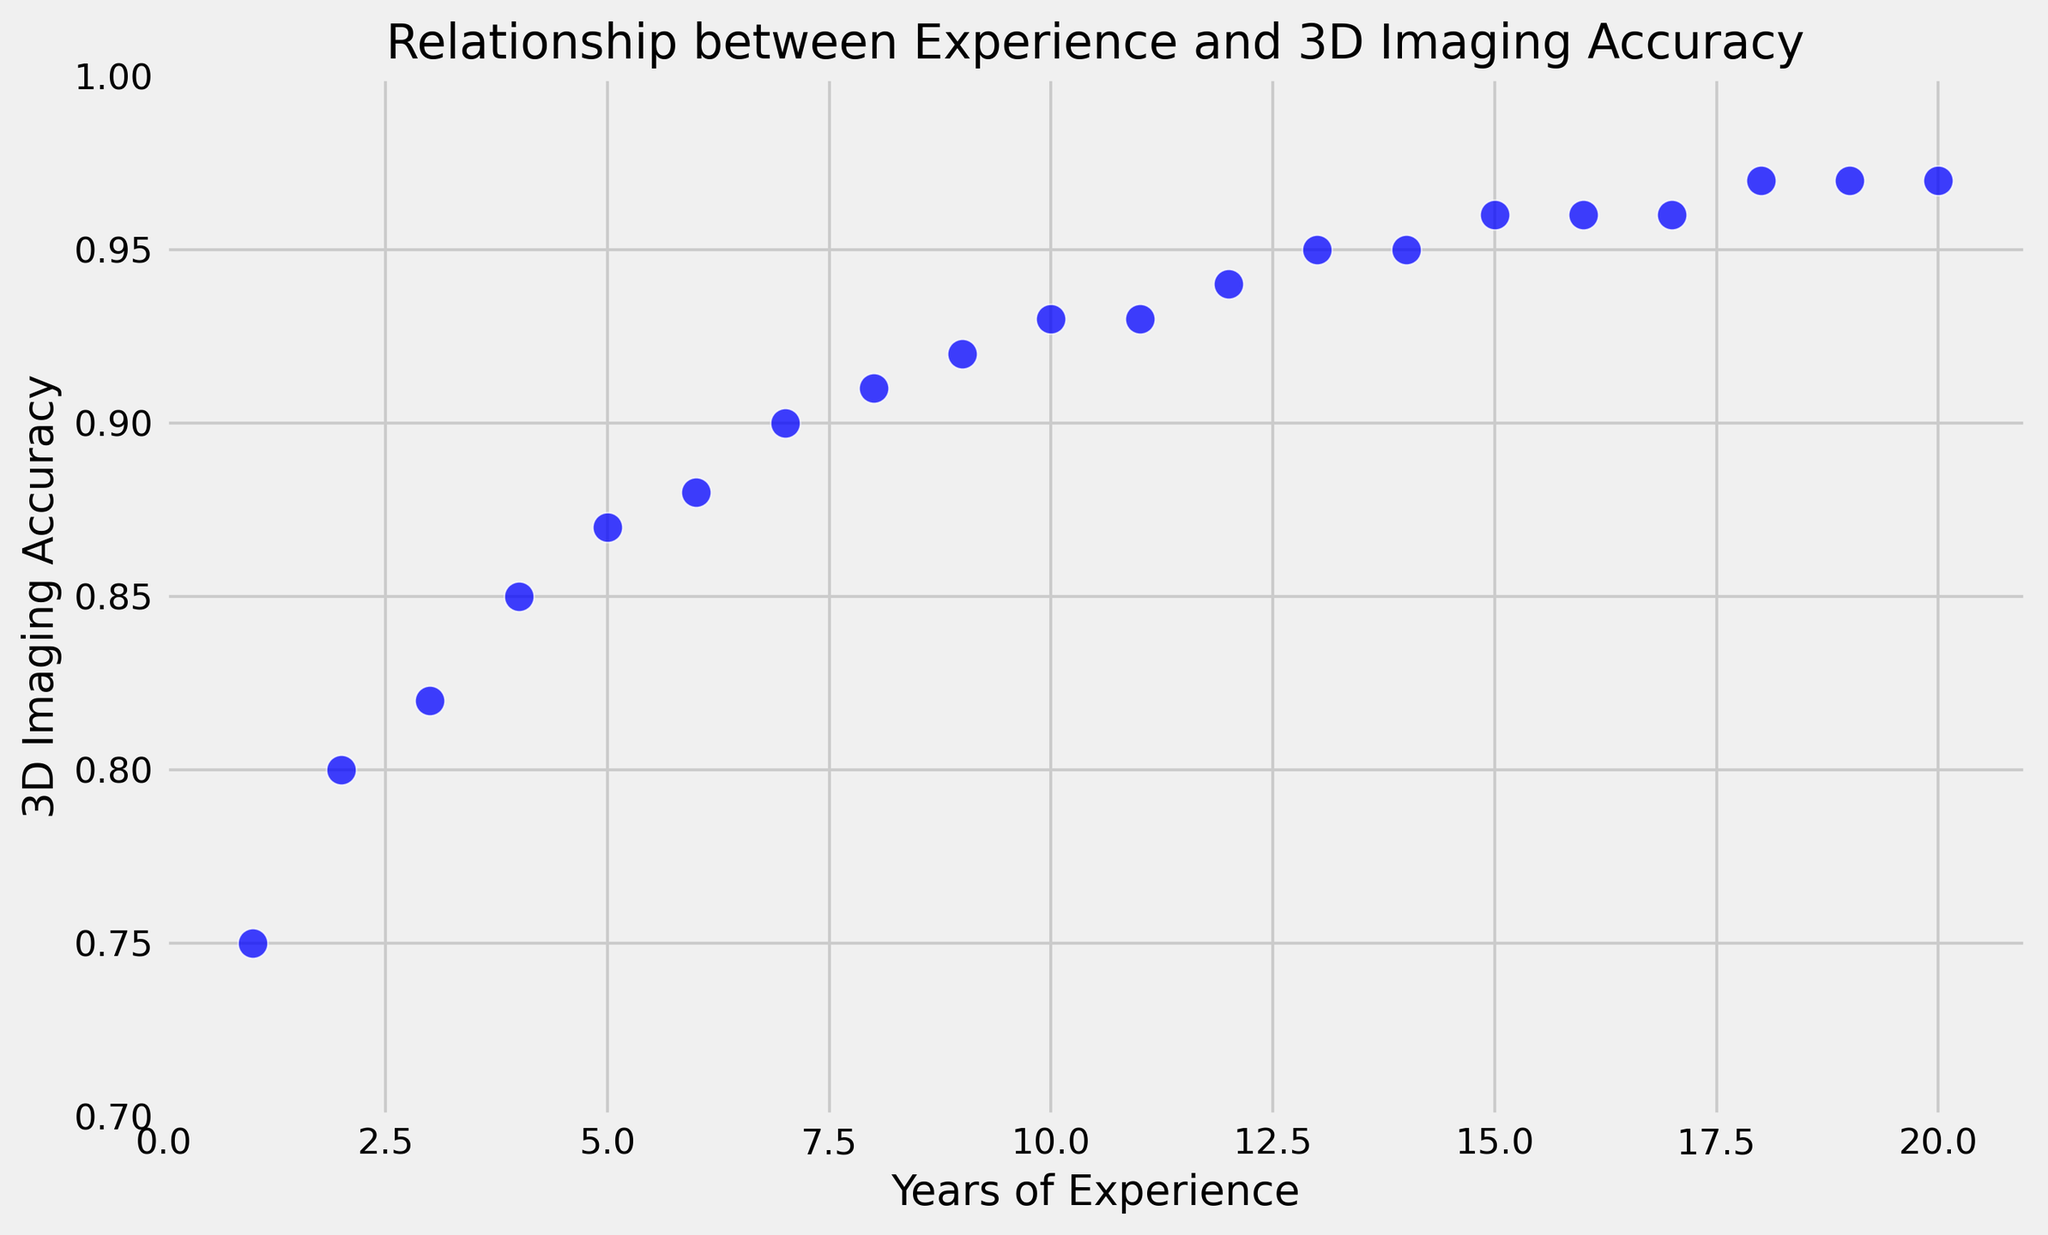What's the general trend depicted in the scatter plot? The scatter plot shows a positive correlation between years of experience and 3D imaging accuracy. As the years of experience increase, the 3D imaging accuracy also improves, indicating that more experienced software engineers tend to produce more accurate 3D imaging results for orthodontic planning.
Answer: Positive correlation What is the highest accuracy observed, and what is the corresponding years of experience? The highest accuracy observed in the scatter plot is 0.97, and this accuracy corresponds to software engineers with 18 to 20 years of experience.
Answer: 0.97, 18-20 years At how many years of experience do 3D imaging accuracy values begin to plateau? From the plot, 3D imaging accuracy values begin to plateau around 15 years of experience, where the accuracy hovers between 0.95 and 0.97.
Answer: 15 years What is the accuracy range for software engineers with 5 to 10 years of experience? For software engineers with 5 to 10 years of experience, the 3D imaging accuracy ranges from 0.87 to 0.93.
Answer: 0.87 to 0.93 How does the accuracy at 10 years of experience compare to the accuracy at 20 years of experience? The accuracy at 10 years of experience is 0.93, whereas the accuracy at 20 years of experience is 0.97. This indicates that the accuracy improves by 0.04 over the additional 10 years of experience.
Answer: Improves by 0.04 Are there any gaps in the data points where no data is present? Visually inspecting the plot, the data points seem consistently distributed with no major gaps for each year of experience from 1 to 20.
Answer: No major gaps What is the average 3D imaging accuracy for software engineers with 1 to 5 years of experience? Adding the accuracies for 1 to 5 years of experience: 0.75 + 0.80 + 0.82 + 0.85 + 0.87 = 4.09. Dividing by 5 gives an average accuracy of 4.09 / 5 = 0.818.
Answer: 0.818 How does accuracy change from 1 year to 4 years of experience? Accuracy at 1 year is 0.75 and at 4 years is 0.85. The change in accuracy is 0.85 - 0.75 = 0.10, showing a 0.10 increase over the 3-year period.
Answer: Increases by 0.10 